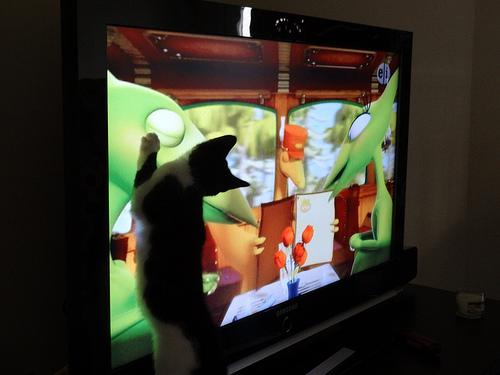Question: what is on?
Choices:
A. The radio.
B. Tv.
C. A fan.
D. The computer.
Answer with the letter. Answer: B Question: what type of scene is this?
Choices:
A. Outdoor.
B. Indoor.
C. In a park.
D. In a hospital.
Answer with the letter. Answer: B Question: where was this photo taken?
Choices:
A. Kitchen.
B. Living room.
C. Bathroom.
D. Garden.
Answer with the letter. Answer: B Question: how is the photo?
Choices:
A. Blurry.
B. Grainy.
C. Washed out.
D. Clear.
Answer with the letter. Answer: D 